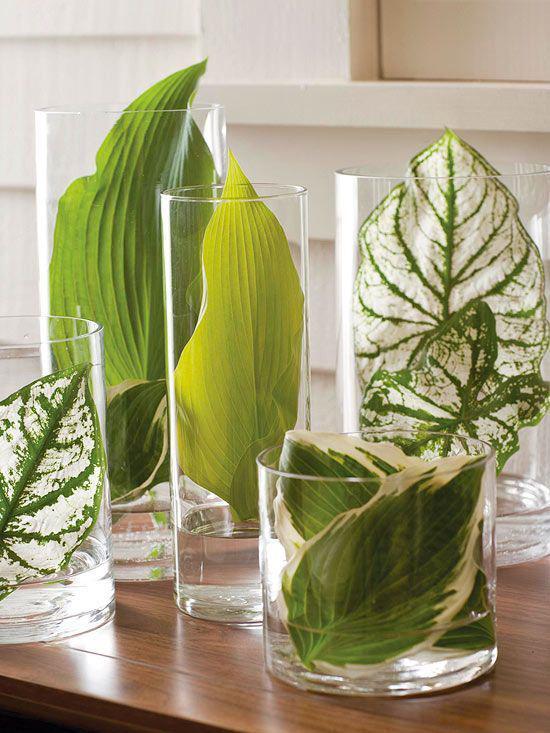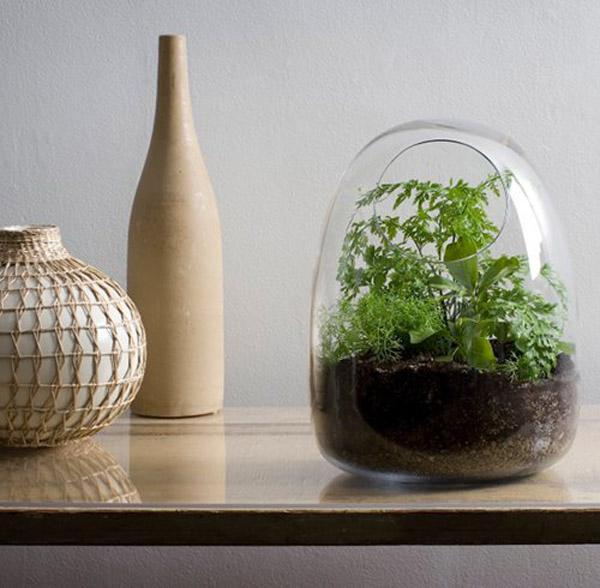The first image is the image on the left, the second image is the image on the right. Assess this claim about the two images: "An image shows several clear glasses on a wood surface, and at least one contains a variegated green-and-whitish leaf.". Correct or not? Answer yes or no. Yes. The first image is the image on the left, the second image is the image on the right. Given the left and right images, does the statement "There are plants in drinking glasses, one of which is short." hold true? Answer yes or no. Yes. 